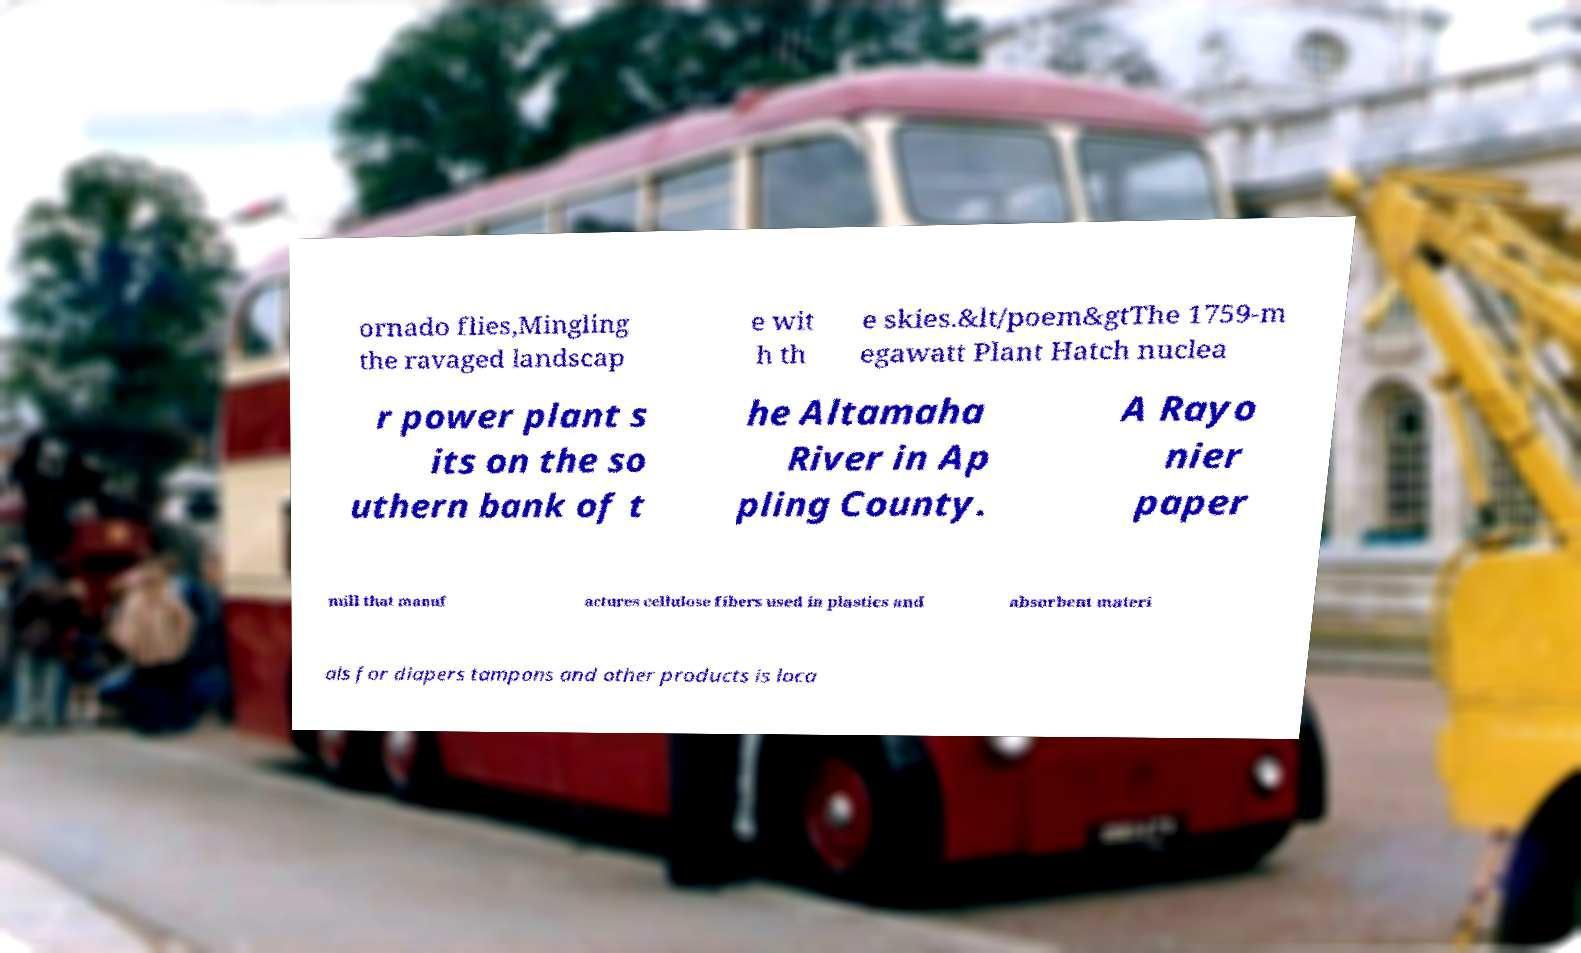For documentation purposes, I need the text within this image transcribed. Could you provide that? ornado flies,Mingling the ravaged landscap e wit h th e skies.&lt/poem&gtThe 1759-m egawatt Plant Hatch nuclea r power plant s its on the so uthern bank of t he Altamaha River in Ap pling County. A Rayo nier paper mill that manuf actures cellulose fibers used in plastics and absorbent materi als for diapers tampons and other products is loca 